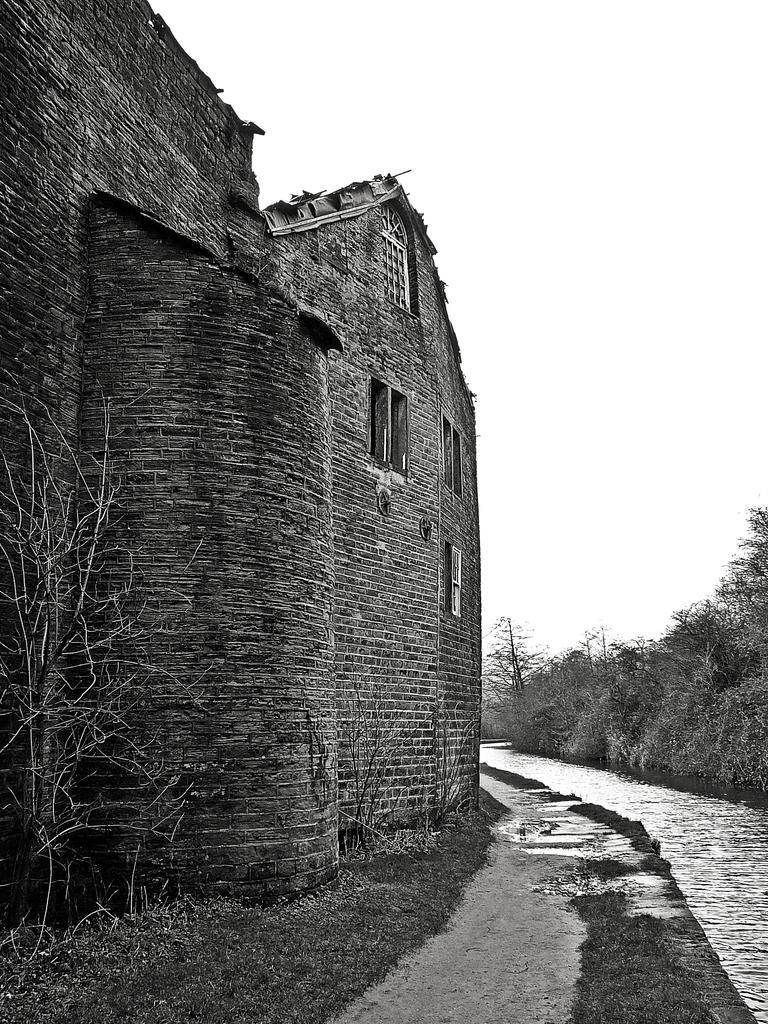What type of structure is present in the image? There is a building in the image. What feature can be observed on the building? The building has glass windows. What type of vegetation is visible in the image? There are trees in the image. What part of the natural environment is visible in the image? The sky is visible in the image. What type of trouble is the sun causing in the image? There is no trouble caused by the sun in the image, as the sun is not depicted as causing any issues. Additionally, the image is in black and white, so the sun is not visible. 